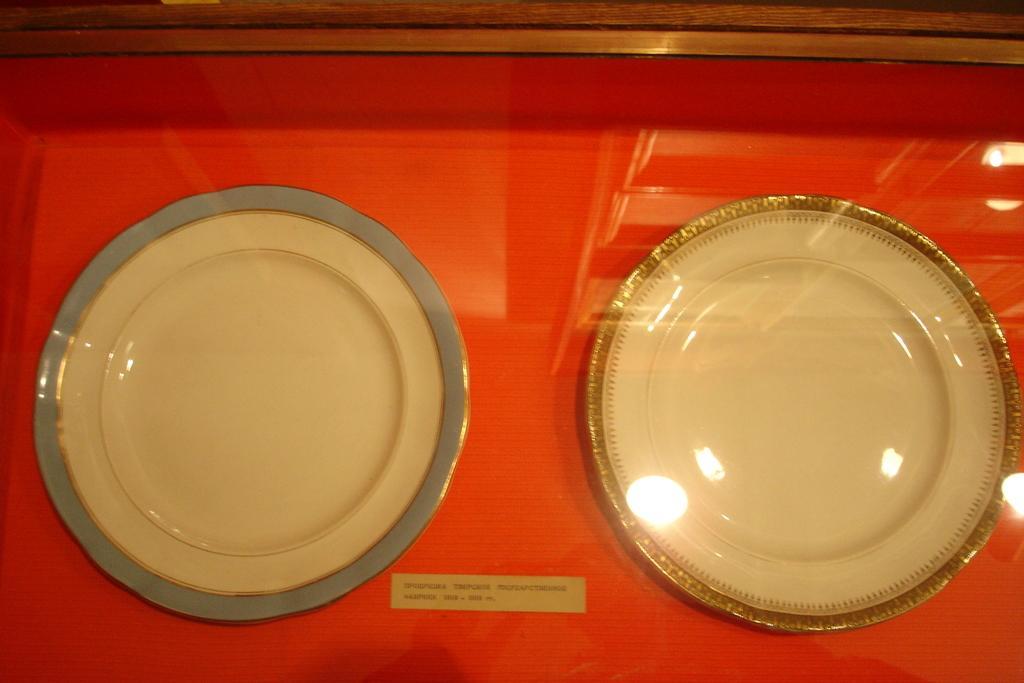Could you give a brief overview of what you see in this image? In this image there are empty plates on the surface which is red in colour and there is some text written on it. 